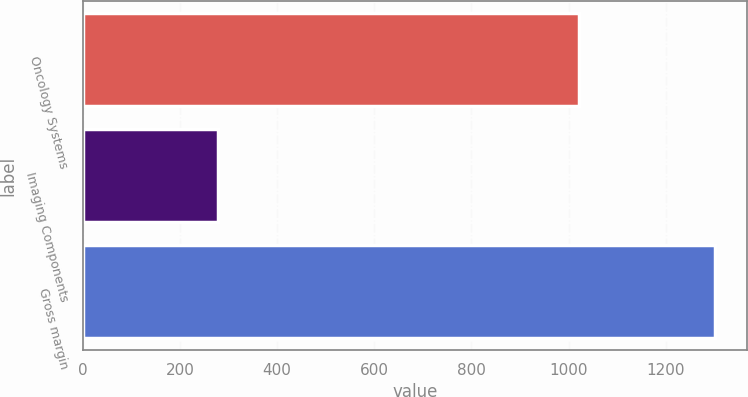Convert chart. <chart><loc_0><loc_0><loc_500><loc_500><bar_chart><fcel>Oncology Systems<fcel>Imaging Components<fcel>Gross margin<nl><fcel>1021.1<fcel>278.6<fcel>1301.7<nl></chart> 